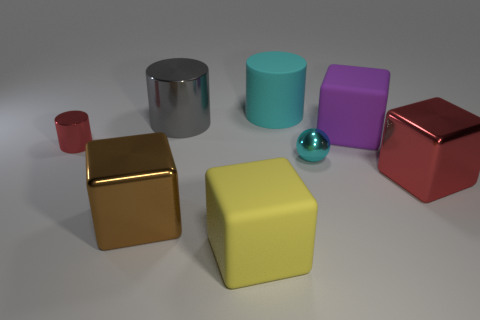Subtract 1 blocks. How many blocks are left? 3 Subtract all blue cubes. Subtract all red spheres. How many cubes are left? 4 Add 2 metal objects. How many objects exist? 10 Subtract all cylinders. How many objects are left? 5 Subtract 1 gray cylinders. How many objects are left? 7 Subtract all tiny green matte things. Subtract all big matte cylinders. How many objects are left? 7 Add 8 small metallic balls. How many small metallic balls are left? 9 Add 6 green matte cubes. How many green matte cubes exist? 6 